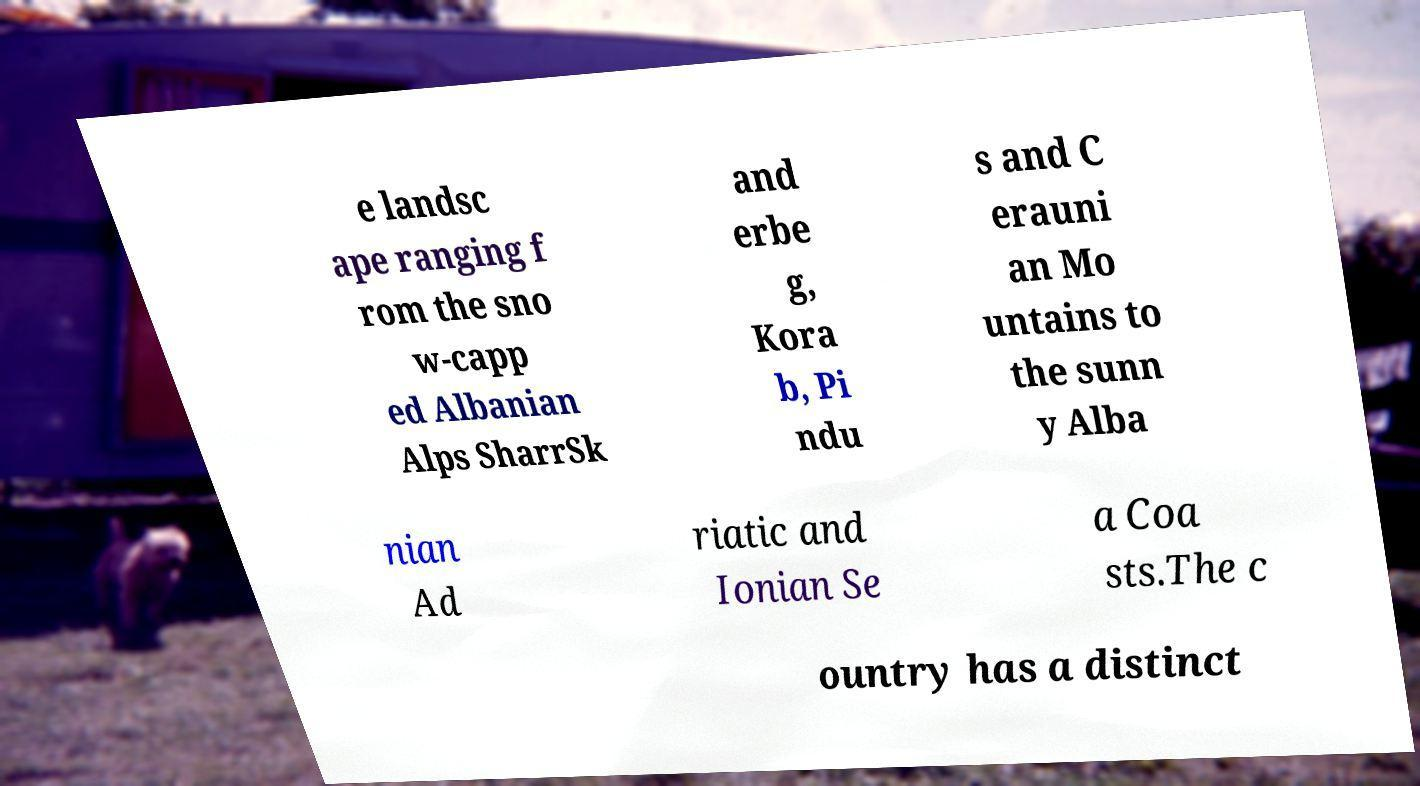For documentation purposes, I need the text within this image transcribed. Could you provide that? e landsc ape ranging f rom the sno w-capp ed Albanian Alps SharrSk and erbe g, Kora b, Pi ndu s and C erauni an Mo untains to the sunn y Alba nian Ad riatic and Ionian Se a Coa sts.The c ountry has a distinct 